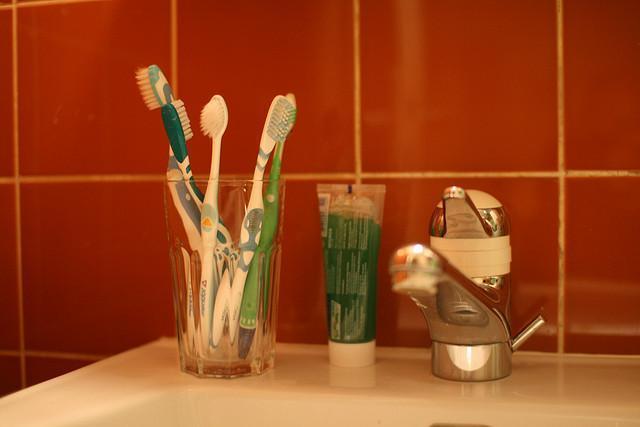How many people live here?
Give a very brief answer. 5. How many toothbrushes can you see?
Give a very brief answer. 4. 